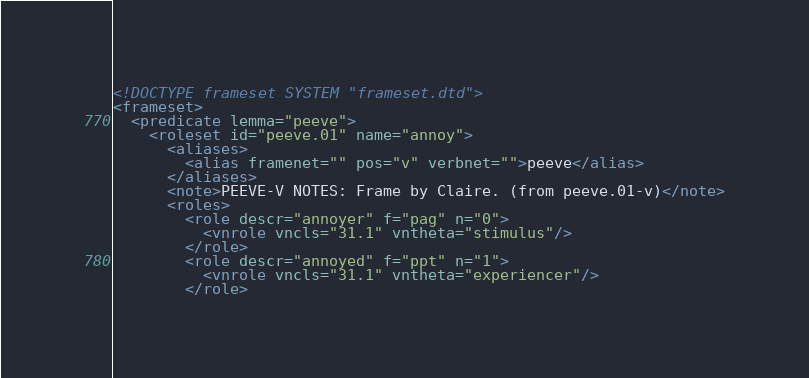Convert code to text. <code><loc_0><loc_0><loc_500><loc_500><_XML_><!DOCTYPE frameset SYSTEM "frameset.dtd">
<frameset>
  <predicate lemma="peeve">
    <roleset id="peeve.01" name="annoy">
      <aliases>
        <alias framenet="" pos="v" verbnet="">peeve</alias>
      </aliases>
      <note>PEEVE-V NOTES: Frame by Claire. (from peeve.01-v)</note>
      <roles>
        <role descr="annoyer" f="pag" n="0">
          <vnrole vncls="31.1" vntheta="stimulus"/>
        </role>
        <role descr="annoyed" f="ppt" n="1">
          <vnrole vncls="31.1" vntheta="experiencer"/>
        </role></code> 